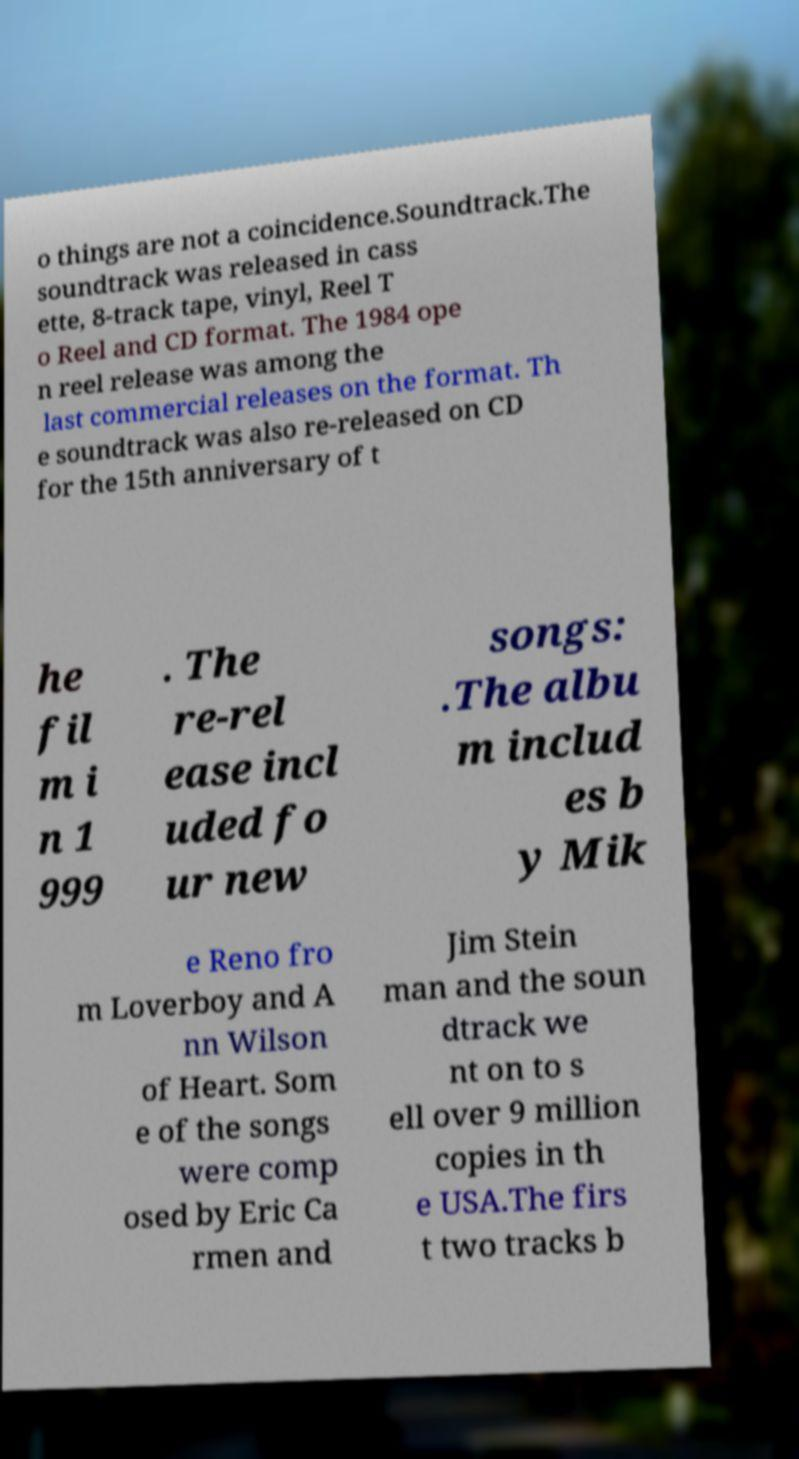Could you extract and type out the text from this image? o things are not a coincidence.Soundtrack.The soundtrack was released in cass ette, 8-track tape, vinyl, Reel T o Reel and CD format. The 1984 ope n reel release was among the last commercial releases on the format. Th e soundtrack was also re-released on CD for the 15th anniversary of t he fil m i n 1 999 . The re-rel ease incl uded fo ur new songs: .The albu m includ es b y Mik e Reno fro m Loverboy and A nn Wilson of Heart. Som e of the songs were comp osed by Eric Ca rmen and Jim Stein man and the soun dtrack we nt on to s ell over 9 million copies in th e USA.The firs t two tracks b 